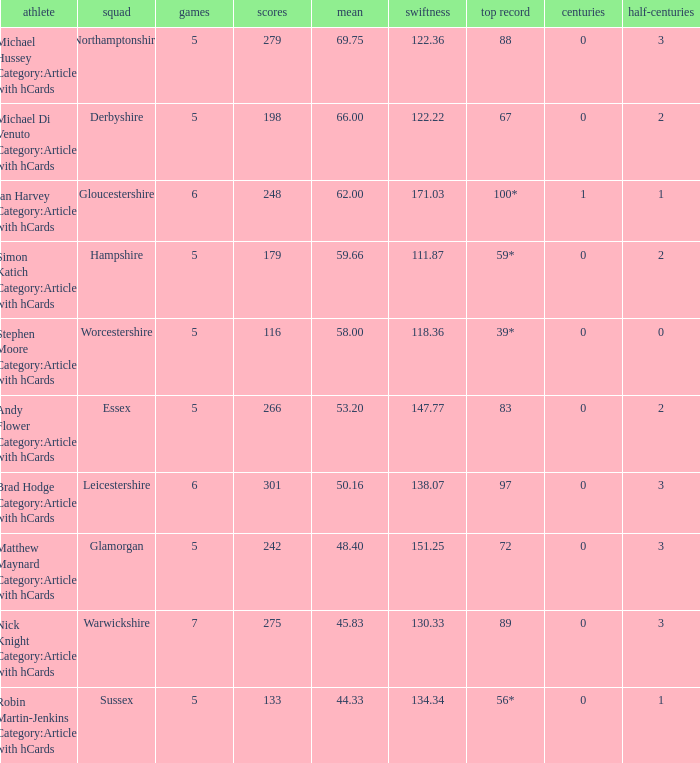When the worcestershire team played 5 games, what was their highest score achieved? 39*. 